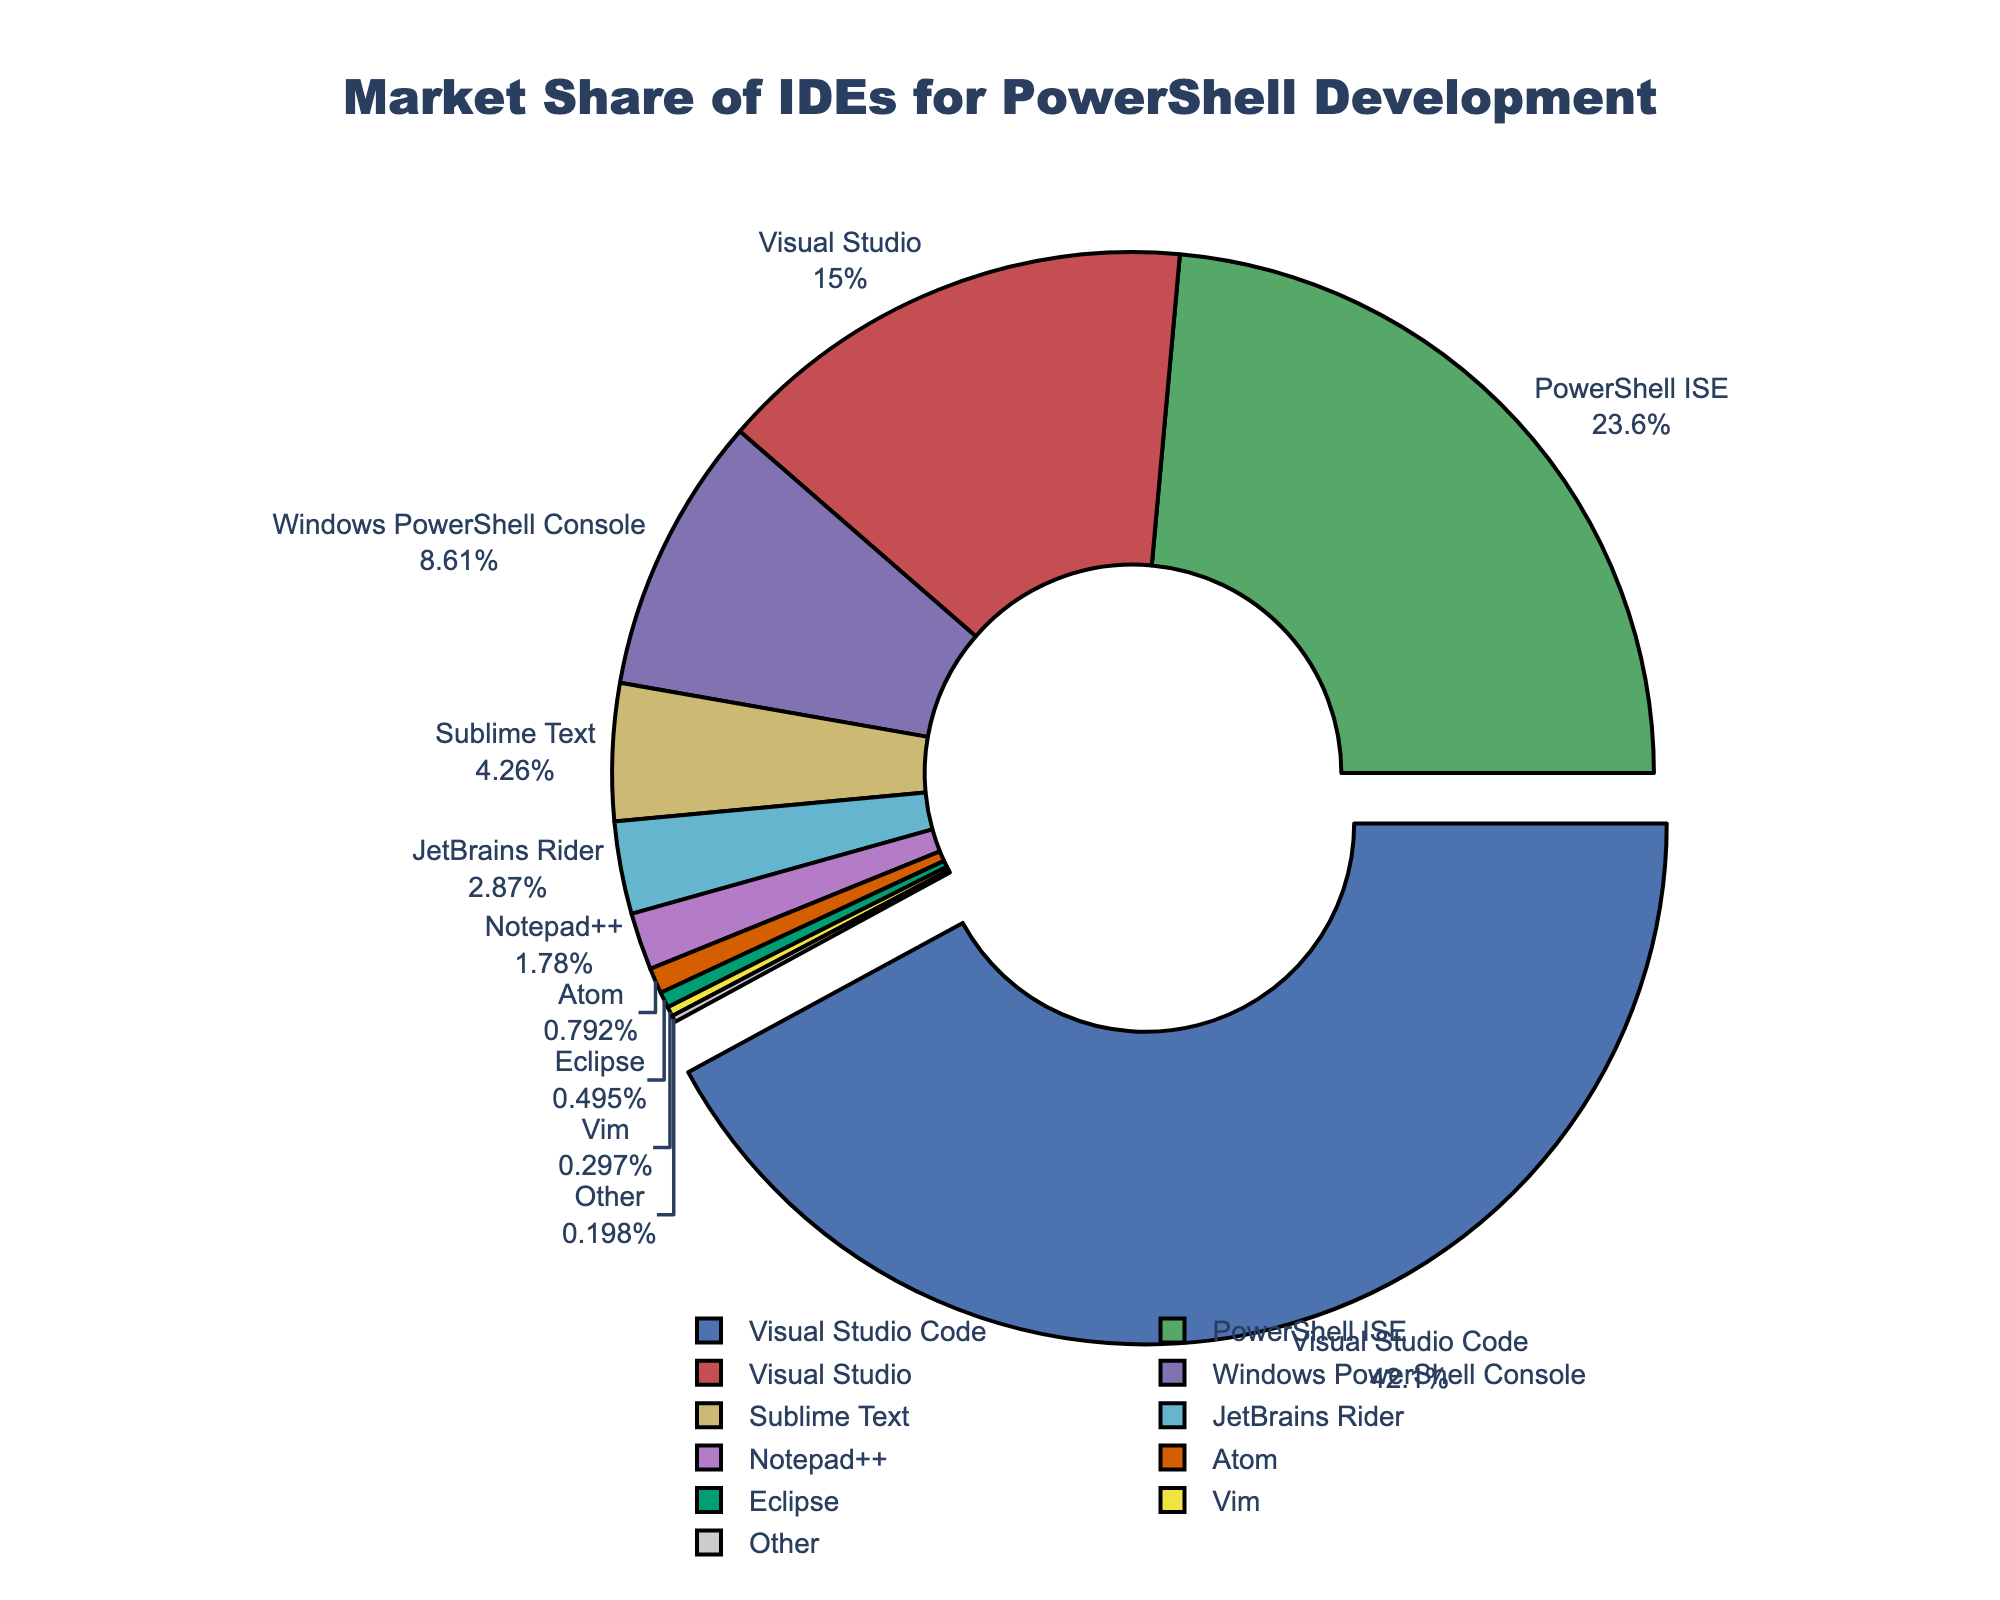What's the market share of Visual Studio Code? Visual Studio Code has a market share of 42.5% as indicated by the label and percentage on the slice of the pie chart.
Answer: 42.5% Which IDE has the smallest market share? The smallest slice belongs to "Other" with a market share of 0.2%, as shown by the label and size of the slice.
Answer: Other What is the combined market share of Visual Studio Code, PowerShell ISE, and Visual Studio? Summing their market shares: Visual Studio Code (42.5%) + PowerShell ISE (23.8%) + Visual Studio (15.2%) gives 42.5 + 23.8 + 15.2 = 81.5%
Answer: 81.5% How does the market share of Sublime Text compare to that of JetBrains Rider? Sublime Text has a market share of 4.3%, while JetBrains Rider has 2.9%. Sublime Text's share is higher.
Answer: Sublime Text has a higher market share Which IDEs have a market share of less than 5%? The slices that are less than 5% are Sublime Text (4.3%), JetBrains Rider (2.9%), Notepad++ (1.8%), Atom (0.8%), Eclipse (0.5%), Vim (0.3%), and Other (0.2%).
Answer: Sublime Text, JetBrains Rider, Notepad++, Atom, Eclipse, Vim, Other What is the difference in market share between PowerShell ISE and Visual Studio? The difference is calculated as 23.8% - 15.2% = 8.6%.
Answer: 8.6% Which slice appears to be the largest visually? The largest slice is visually identified as Visual Studio Code, both from its size and the percentage data.
Answer: Visual Studio Code What is the total market share of the bottom three IDEs? Summing the market shares of Atom (0.8%), Eclipse (0.5%), and Vim (0.3%): 0.8 + 0.5 + 0.3 = 1.6%.
Answer: 1.6% Are there more IDEs with market shares above or below 10%? Counting the slices: Above 10% are three (Visual Studio Code, PowerShell ISE, Visual Studio), Below 10% are eight (Windows PowerShell Console, Sublime Text, JetBrains Rider, Notepad++, Atom, Eclipse, Vim, Other). There are more below 10%.
Answer: Below 10% 